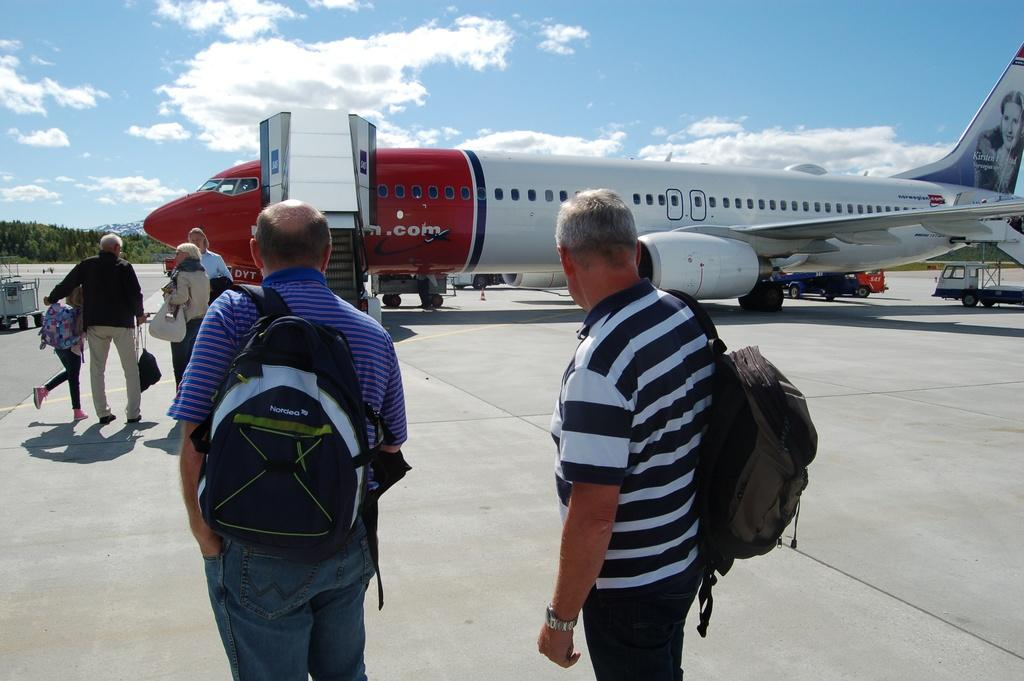<image>
Create a compact narrative representing the image presented. Several people wait to board an airplane from Norwegian.com. 